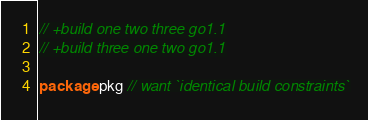<code> <loc_0><loc_0><loc_500><loc_500><_Go_>// +build one two three go1.1
// +build three one two go1.1

package pkg // want `identical build constraints`
</code> 